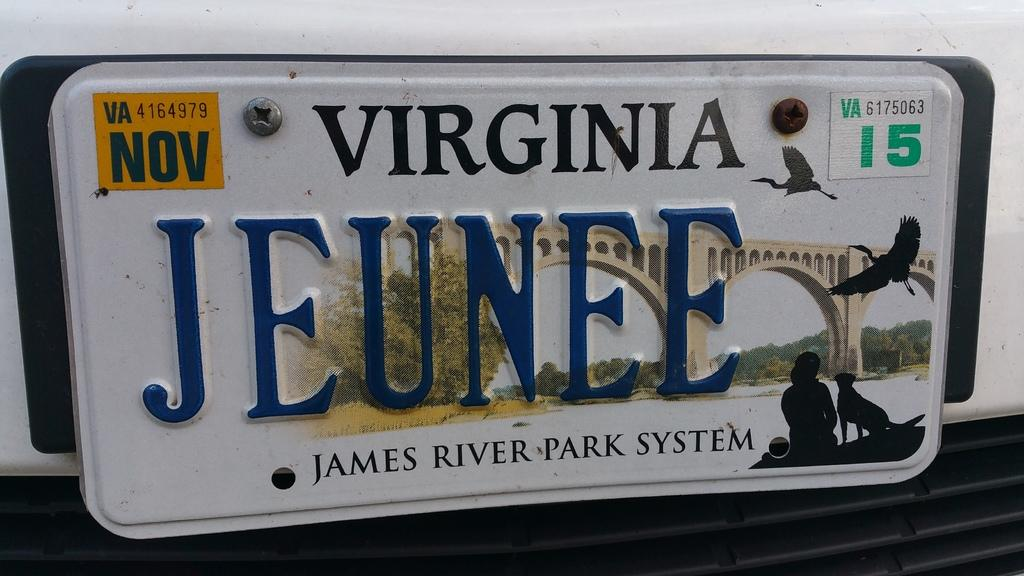Provide a one-sentence caption for the provided image. A Virginia license plate that reads Jeunee with a picture of a bridge in the background, above the words James River Park System.. 